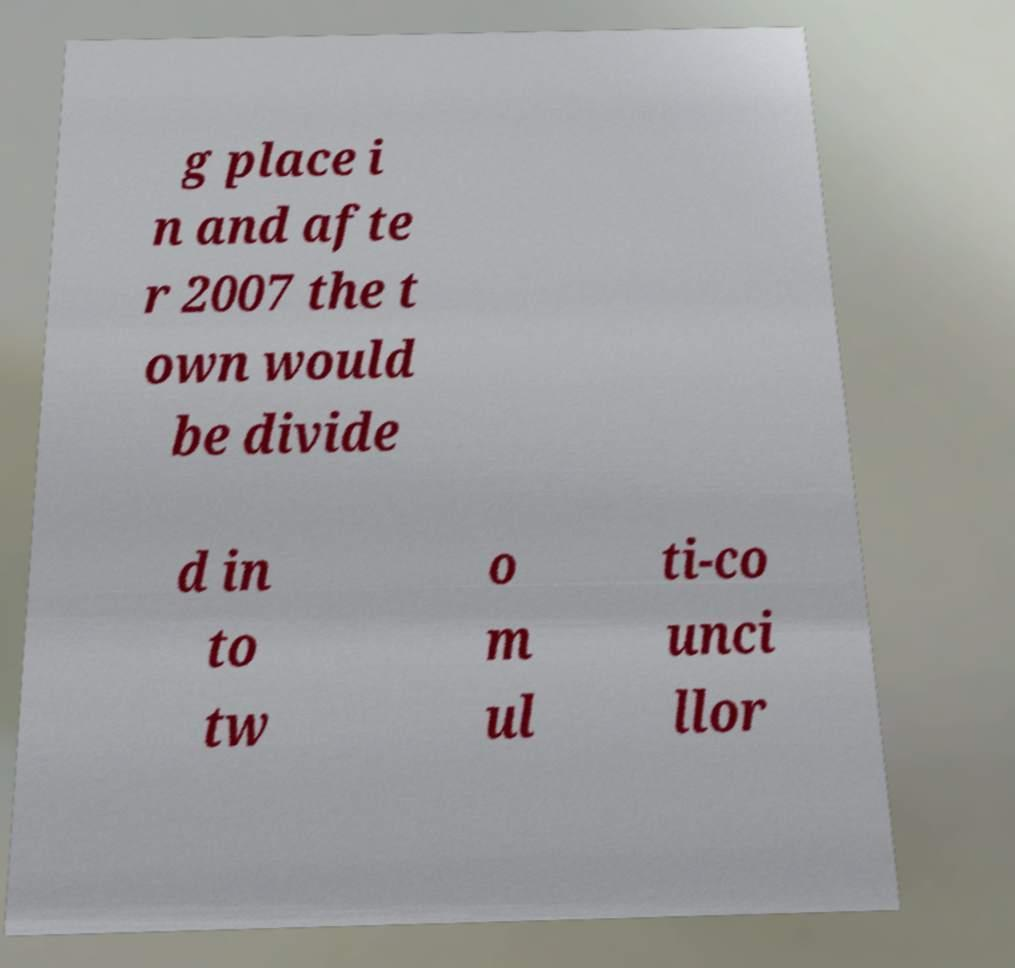What messages or text are displayed in this image? I need them in a readable, typed format. g place i n and afte r 2007 the t own would be divide d in to tw o m ul ti-co unci llor 